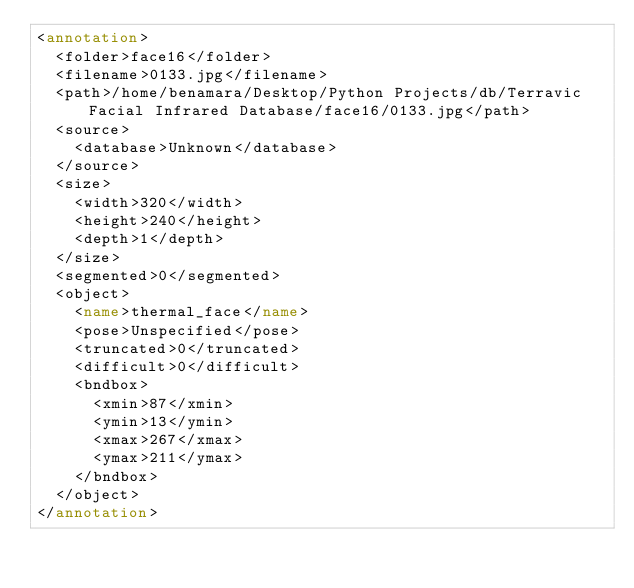<code> <loc_0><loc_0><loc_500><loc_500><_XML_><annotation>
	<folder>face16</folder>
	<filename>0133.jpg</filename>
	<path>/home/benamara/Desktop/Python Projects/db/Terravic Facial Infrared Database/face16/0133.jpg</path>
	<source>
		<database>Unknown</database>
	</source>
	<size>
		<width>320</width>
		<height>240</height>
		<depth>1</depth>
	</size>
	<segmented>0</segmented>
	<object>
		<name>thermal_face</name>
		<pose>Unspecified</pose>
		<truncated>0</truncated>
		<difficult>0</difficult>
		<bndbox>
			<xmin>87</xmin>
			<ymin>13</ymin>
			<xmax>267</xmax>
			<ymax>211</ymax>
		</bndbox>
	</object>
</annotation>
</code> 